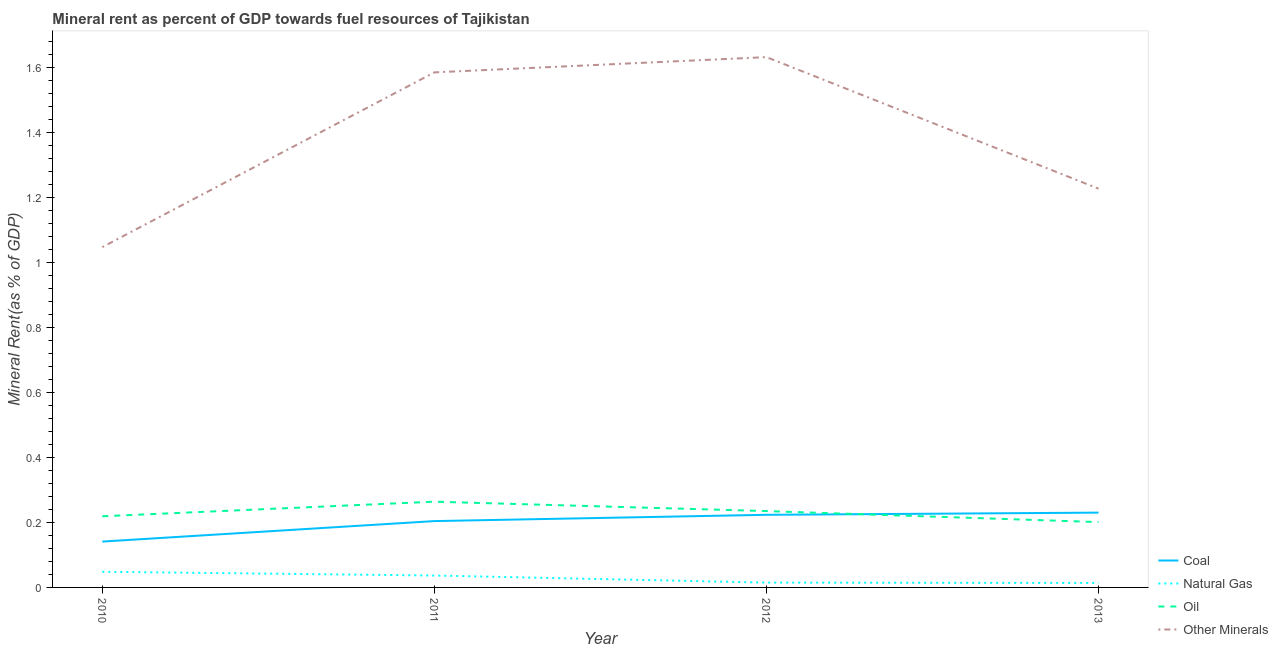How many different coloured lines are there?
Your answer should be very brief. 4. Is the number of lines equal to the number of legend labels?
Your response must be concise. Yes. What is the natural gas rent in 2011?
Your response must be concise. 0.04. Across all years, what is the maximum coal rent?
Offer a terse response. 0.23. Across all years, what is the minimum natural gas rent?
Make the answer very short. 0.01. In which year was the oil rent minimum?
Provide a short and direct response. 2013. What is the total coal rent in the graph?
Your answer should be very brief. 0.8. What is the difference between the  rent of other minerals in 2010 and that in 2013?
Ensure brevity in your answer.  -0.18. What is the difference between the oil rent in 2012 and the  rent of other minerals in 2013?
Offer a very short reply. -0.99. What is the average natural gas rent per year?
Offer a very short reply. 0.03. In the year 2010, what is the difference between the  rent of other minerals and oil rent?
Make the answer very short. 0.83. What is the ratio of the  rent of other minerals in 2011 to that in 2012?
Make the answer very short. 0.97. Is the difference between the natural gas rent in 2010 and 2011 greater than the difference between the oil rent in 2010 and 2011?
Offer a very short reply. Yes. What is the difference between the highest and the second highest  rent of other minerals?
Provide a short and direct response. 0.05. What is the difference between the highest and the lowest oil rent?
Provide a short and direct response. 0.06. In how many years, is the  rent of other minerals greater than the average  rent of other minerals taken over all years?
Make the answer very short. 2. Is the sum of the oil rent in 2011 and 2013 greater than the maximum natural gas rent across all years?
Give a very brief answer. Yes. Is it the case that in every year, the sum of the natural gas rent and oil rent is greater than the sum of coal rent and  rent of other minerals?
Ensure brevity in your answer.  No. Does the natural gas rent monotonically increase over the years?
Give a very brief answer. No. Is the oil rent strictly greater than the  rent of other minerals over the years?
Make the answer very short. No. How many lines are there?
Offer a very short reply. 4. What is the difference between two consecutive major ticks on the Y-axis?
Provide a short and direct response. 0.2. Does the graph contain any zero values?
Provide a short and direct response. No. How many legend labels are there?
Your answer should be compact. 4. What is the title of the graph?
Provide a succinct answer. Mineral rent as percent of GDP towards fuel resources of Tajikistan. Does "Mammal species" appear as one of the legend labels in the graph?
Ensure brevity in your answer.  No. What is the label or title of the Y-axis?
Ensure brevity in your answer.  Mineral Rent(as % of GDP). What is the Mineral Rent(as % of GDP) of Coal in 2010?
Make the answer very short. 0.14. What is the Mineral Rent(as % of GDP) of Natural Gas in 2010?
Your response must be concise. 0.05. What is the Mineral Rent(as % of GDP) in Oil in 2010?
Your answer should be compact. 0.22. What is the Mineral Rent(as % of GDP) in Other Minerals in 2010?
Keep it short and to the point. 1.05. What is the Mineral Rent(as % of GDP) in Coal in 2011?
Your answer should be compact. 0.2. What is the Mineral Rent(as % of GDP) of Natural Gas in 2011?
Your answer should be compact. 0.04. What is the Mineral Rent(as % of GDP) in Oil in 2011?
Provide a succinct answer. 0.26. What is the Mineral Rent(as % of GDP) of Other Minerals in 2011?
Your response must be concise. 1.58. What is the Mineral Rent(as % of GDP) of Coal in 2012?
Your answer should be very brief. 0.22. What is the Mineral Rent(as % of GDP) of Natural Gas in 2012?
Keep it short and to the point. 0.01. What is the Mineral Rent(as % of GDP) in Oil in 2012?
Keep it short and to the point. 0.23. What is the Mineral Rent(as % of GDP) in Other Minerals in 2012?
Ensure brevity in your answer.  1.63. What is the Mineral Rent(as % of GDP) in Coal in 2013?
Ensure brevity in your answer.  0.23. What is the Mineral Rent(as % of GDP) of Natural Gas in 2013?
Your answer should be compact. 0.01. What is the Mineral Rent(as % of GDP) of Oil in 2013?
Your answer should be compact. 0.2. What is the Mineral Rent(as % of GDP) in Other Minerals in 2013?
Make the answer very short. 1.23. Across all years, what is the maximum Mineral Rent(as % of GDP) in Coal?
Provide a short and direct response. 0.23. Across all years, what is the maximum Mineral Rent(as % of GDP) in Natural Gas?
Your response must be concise. 0.05. Across all years, what is the maximum Mineral Rent(as % of GDP) of Oil?
Offer a very short reply. 0.26. Across all years, what is the maximum Mineral Rent(as % of GDP) in Other Minerals?
Your answer should be very brief. 1.63. Across all years, what is the minimum Mineral Rent(as % of GDP) of Coal?
Offer a terse response. 0.14. Across all years, what is the minimum Mineral Rent(as % of GDP) in Natural Gas?
Ensure brevity in your answer.  0.01. Across all years, what is the minimum Mineral Rent(as % of GDP) of Oil?
Your response must be concise. 0.2. Across all years, what is the minimum Mineral Rent(as % of GDP) in Other Minerals?
Keep it short and to the point. 1.05. What is the total Mineral Rent(as % of GDP) in Coal in the graph?
Your answer should be very brief. 0.8. What is the total Mineral Rent(as % of GDP) of Natural Gas in the graph?
Keep it short and to the point. 0.11. What is the total Mineral Rent(as % of GDP) of Oil in the graph?
Offer a very short reply. 0.92. What is the total Mineral Rent(as % of GDP) of Other Minerals in the graph?
Your answer should be compact. 5.49. What is the difference between the Mineral Rent(as % of GDP) in Coal in 2010 and that in 2011?
Keep it short and to the point. -0.06. What is the difference between the Mineral Rent(as % of GDP) in Natural Gas in 2010 and that in 2011?
Offer a terse response. 0.01. What is the difference between the Mineral Rent(as % of GDP) in Oil in 2010 and that in 2011?
Offer a terse response. -0.04. What is the difference between the Mineral Rent(as % of GDP) of Other Minerals in 2010 and that in 2011?
Offer a terse response. -0.54. What is the difference between the Mineral Rent(as % of GDP) of Coal in 2010 and that in 2012?
Ensure brevity in your answer.  -0.08. What is the difference between the Mineral Rent(as % of GDP) of Natural Gas in 2010 and that in 2012?
Keep it short and to the point. 0.03. What is the difference between the Mineral Rent(as % of GDP) in Oil in 2010 and that in 2012?
Your answer should be compact. -0.02. What is the difference between the Mineral Rent(as % of GDP) of Other Minerals in 2010 and that in 2012?
Your answer should be very brief. -0.58. What is the difference between the Mineral Rent(as % of GDP) in Coal in 2010 and that in 2013?
Your answer should be very brief. -0.09. What is the difference between the Mineral Rent(as % of GDP) of Natural Gas in 2010 and that in 2013?
Keep it short and to the point. 0.03. What is the difference between the Mineral Rent(as % of GDP) in Oil in 2010 and that in 2013?
Ensure brevity in your answer.  0.02. What is the difference between the Mineral Rent(as % of GDP) in Other Minerals in 2010 and that in 2013?
Make the answer very short. -0.18. What is the difference between the Mineral Rent(as % of GDP) in Coal in 2011 and that in 2012?
Give a very brief answer. -0.02. What is the difference between the Mineral Rent(as % of GDP) in Natural Gas in 2011 and that in 2012?
Keep it short and to the point. 0.02. What is the difference between the Mineral Rent(as % of GDP) of Oil in 2011 and that in 2012?
Keep it short and to the point. 0.03. What is the difference between the Mineral Rent(as % of GDP) in Other Minerals in 2011 and that in 2012?
Your answer should be compact. -0.05. What is the difference between the Mineral Rent(as % of GDP) in Coal in 2011 and that in 2013?
Ensure brevity in your answer.  -0.03. What is the difference between the Mineral Rent(as % of GDP) of Natural Gas in 2011 and that in 2013?
Ensure brevity in your answer.  0.02. What is the difference between the Mineral Rent(as % of GDP) of Oil in 2011 and that in 2013?
Provide a succinct answer. 0.06. What is the difference between the Mineral Rent(as % of GDP) of Other Minerals in 2011 and that in 2013?
Your answer should be very brief. 0.36. What is the difference between the Mineral Rent(as % of GDP) in Coal in 2012 and that in 2013?
Offer a terse response. -0.01. What is the difference between the Mineral Rent(as % of GDP) in Natural Gas in 2012 and that in 2013?
Provide a short and direct response. 0. What is the difference between the Mineral Rent(as % of GDP) in Oil in 2012 and that in 2013?
Ensure brevity in your answer.  0.03. What is the difference between the Mineral Rent(as % of GDP) in Other Minerals in 2012 and that in 2013?
Your response must be concise. 0.4. What is the difference between the Mineral Rent(as % of GDP) in Coal in 2010 and the Mineral Rent(as % of GDP) in Natural Gas in 2011?
Your answer should be very brief. 0.1. What is the difference between the Mineral Rent(as % of GDP) in Coal in 2010 and the Mineral Rent(as % of GDP) in Oil in 2011?
Provide a succinct answer. -0.12. What is the difference between the Mineral Rent(as % of GDP) of Coal in 2010 and the Mineral Rent(as % of GDP) of Other Minerals in 2011?
Offer a very short reply. -1.44. What is the difference between the Mineral Rent(as % of GDP) in Natural Gas in 2010 and the Mineral Rent(as % of GDP) in Oil in 2011?
Your response must be concise. -0.22. What is the difference between the Mineral Rent(as % of GDP) in Natural Gas in 2010 and the Mineral Rent(as % of GDP) in Other Minerals in 2011?
Your response must be concise. -1.54. What is the difference between the Mineral Rent(as % of GDP) of Oil in 2010 and the Mineral Rent(as % of GDP) of Other Minerals in 2011?
Your response must be concise. -1.36. What is the difference between the Mineral Rent(as % of GDP) of Coal in 2010 and the Mineral Rent(as % of GDP) of Natural Gas in 2012?
Provide a short and direct response. 0.13. What is the difference between the Mineral Rent(as % of GDP) in Coal in 2010 and the Mineral Rent(as % of GDP) in Oil in 2012?
Your answer should be compact. -0.09. What is the difference between the Mineral Rent(as % of GDP) of Coal in 2010 and the Mineral Rent(as % of GDP) of Other Minerals in 2012?
Your answer should be compact. -1.49. What is the difference between the Mineral Rent(as % of GDP) of Natural Gas in 2010 and the Mineral Rent(as % of GDP) of Oil in 2012?
Your answer should be compact. -0.19. What is the difference between the Mineral Rent(as % of GDP) of Natural Gas in 2010 and the Mineral Rent(as % of GDP) of Other Minerals in 2012?
Your answer should be very brief. -1.58. What is the difference between the Mineral Rent(as % of GDP) of Oil in 2010 and the Mineral Rent(as % of GDP) of Other Minerals in 2012?
Provide a short and direct response. -1.41. What is the difference between the Mineral Rent(as % of GDP) in Coal in 2010 and the Mineral Rent(as % of GDP) in Natural Gas in 2013?
Your answer should be very brief. 0.13. What is the difference between the Mineral Rent(as % of GDP) in Coal in 2010 and the Mineral Rent(as % of GDP) in Oil in 2013?
Provide a short and direct response. -0.06. What is the difference between the Mineral Rent(as % of GDP) of Coal in 2010 and the Mineral Rent(as % of GDP) of Other Minerals in 2013?
Keep it short and to the point. -1.09. What is the difference between the Mineral Rent(as % of GDP) of Natural Gas in 2010 and the Mineral Rent(as % of GDP) of Oil in 2013?
Ensure brevity in your answer.  -0.15. What is the difference between the Mineral Rent(as % of GDP) of Natural Gas in 2010 and the Mineral Rent(as % of GDP) of Other Minerals in 2013?
Ensure brevity in your answer.  -1.18. What is the difference between the Mineral Rent(as % of GDP) in Oil in 2010 and the Mineral Rent(as % of GDP) in Other Minerals in 2013?
Make the answer very short. -1.01. What is the difference between the Mineral Rent(as % of GDP) of Coal in 2011 and the Mineral Rent(as % of GDP) of Natural Gas in 2012?
Make the answer very short. 0.19. What is the difference between the Mineral Rent(as % of GDP) in Coal in 2011 and the Mineral Rent(as % of GDP) in Oil in 2012?
Ensure brevity in your answer.  -0.03. What is the difference between the Mineral Rent(as % of GDP) of Coal in 2011 and the Mineral Rent(as % of GDP) of Other Minerals in 2012?
Provide a succinct answer. -1.43. What is the difference between the Mineral Rent(as % of GDP) in Natural Gas in 2011 and the Mineral Rent(as % of GDP) in Oil in 2012?
Offer a terse response. -0.2. What is the difference between the Mineral Rent(as % of GDP) in Natural Gas in 2011 and the Mineral Rent(as % of GDP) in Other Minerals in 2012?
Offer a very short reply. -1.59. What is the difference between the Mineral Rent(as % of GDP) in Oil in 2011 and the Mineral Rent(as % of GDP) in Other Minerals in 2012?
Ensure brevity in your answer.  -1.37. What is the difference between the Mineral Rent(as % of GDP) of Coal in 2011 and the Mineral Rent(as % of GDP) of Natural Gas in 2013?
Provide a succinct answer. 0.19. What is the difference between the Mineral Rent(as % of GDP) in Coal in 2011 and the Mineral Rent(as % of GDP) in Oil in 2013?
Your answer should be compact. 0. What is the difference between the Mineral Rent(as % of GDP) in Coal in 2011 and the Mineral Rent(as % of GDP) in Other Minerals in 2013?
Provide a short and direct response. -1.02. What is the difference between the Mineral Rent(as % of GDP) in Natural Gas in 2011 and the Mineral Rent(as % of GDP) in Oil in 2013?
Ensure brevity in your answer.  -0.16. What is the difference between the Mineral Rent(as % of GDP) in Natural Gas in 2011 and the Mineral Rent(as % of GDP) in Other Minerals in 2013?
Your response must be concise. -1.19. What is the difference between the Mineral Rent(as % of GDP) of Oil in 2011 and the Mineral Rent(as % of GDP) of Other Minerals in 2013?
Your answer should be very brief. -0.96. What is the difference between the Mineral Rent(as % of GDP) in Coal in 2012 and the Mineral Rent(as % of GDP) in Natural Gas in 2013?
Ensure brevity in your answer.  0.21. What is the difference between the Mineral Rent(as % of GDP) of Coal in 2012 and the Mineral Rent(as % of GDP) of Oil in 2013?
Your response must be concise. 0.02. What is the difference between the Mineral Rent(as % of GDP) of Coal in 2012 and the Mineral Rent(as % of GDP) of Other Minerals in 2013?
Make the answer very short. -1. What is the difference between the Mineral Rent(as % of GDP) of Natural Gas in 2012 and the Mineral Rent(as % of GDP) of Oil in 2013?
Keep it short and to the point. -0.19. What is the difference between the Mineral Rent(as % of GDP) in Natural Gas in 2012 and the Mineral Rent(as % of GDP) in Other Minerals in 2013?
Offer a terse response. -1.21. What is the difference between the Mineral Rent(as % of GDP) of Oil in 2012 and the Mineral Rent(as % of GDP) of Other Minerals in 2013?
Your answer should be compact. -0.99. What is the average Mineral Rent(as % of GDP) in Coal per year?
Your answer should be very brief. 0.2. What is the average Mineral Rent(as % of GDP) of Natural Gas per year?
Keep it short and to the point. 0.03. What is the average Mineral Rent(as % of GDP) in Oil per year?
Your answer should be very brief. 0.23. What is the average Mineral Rent(as % of GDP) in Other Minerals per year?
Offer a terse response. 1.37. In the year 2010, what is the difference between the Mineral Rent(as % of GDP) of Coal and Mineral Rent(as % of GDP) of Natural Gas?
Your response must be concise. 0.09. In the year 2010, what is the difference between the Mineral Rent(as % of GDP) of Coal and Mineral Rent(as % of GDP) of Oil?
Your answer should be very brief. -0.08. In the year 2010, what is the difference between the Mineral Rent(as % of GDP) of Coal and Mineral Rent(as % of GDP) of Other Minerals?
Keep it short and to the point. -0.91. In the year 2010, what is the difference between the Mineral Rent(as % of GDP) of Natural Gas and Mineral Rent(as % of GDP) of Oil?
Offer a very short reply. -0.17. In the year 2010, what is the difference between the Mineral Rent(as % of GDP) in Natural Gas and Mineral Rent(as % of GDP) in Other Minerals?
Offer a terse response. -1. In the year 2010, what is the difference between the Mineral Rent(as % of GDP) of Oil and Mineral Rent(as % of GDP) of Other Minerals?
Make the answer very short. -0.83. In the year 2011, what is the difference between the Mineral Rent(as % of GDP) in Coal and Mineral Rent(as % of GDP) in Natural Gas?
Make the answer very short. 0.17. In the year 2011, what is the difference between the Mineral Rent(as % of GDP) in Coal and Mineral Rent(as % of GDP) in Oil?
Keep it short and to the point. -0.06. In the year 2011, what is the difference between the Mineral Rent(as % of GDP) in Coal and Mineral Rent(as % of GDP) in Other Minerals?
Your answer should be very brief. -1.38. In the year 2011, what is the difference between the Mineral Rent(as % of GDP) in Natural Gas and Mineral Rent(as % of GDP) in Oil?
Make the answer very short. -0.23. In the year 2011, what is the difference between the Mineral Rent(as % of GDP) of Natural Gas and Mineral Rent(as % of GDP) of Other Minerals?
Provide a short and direct response. -1.55. In the year 2011, what is the difference between the Mineral Rent(as % of GDP) in Oil and Mineral Rent(as % of GDP) in Other Minerals?
Offer a terse response. -1.32. In the year 2012, what is the difference between the Mineral Rent(as % of GDP) in Coal and Mineral Rent(as % of GDP) in Natural Gas?
Your answer should be very brief. 0.21. In the year 2012, what is the difference between the Mineral Rent(as % of GDP) in Coal and Mineral Rent(as % of GDP) in Oil?
Make the answer very short. -0.01. In the year 2012, what is the difference between the Mineral Rent(as % of GDP) in Coal and Mineral Rent(as % of GDP) in Other Minerals?
Offer a terse response. -1.41. In the year 2012, what is the difference between the Mineral Rent(as % of GDP) of Natural Gas and Mineral Rent(as % of GDP) of Oil?
Ensure brevity in your answer.  -0.22. In the year 2012, what is the difference between the Mineral Rent(as % of GDP) of Natural Gas and Mineral Rent(as % of GDP) of Other Minerals?
Ensure brevity in your answer.  -1.62. In the year 2012, what is the difference between the Mineral Rent(as % of GDP) of Oil and Mineral Rent(as % of GDP) of Other Minerals?
Offer a very short reply. -1.4. In the year 2013, what is the difference between the Mineral Rent(as % of GDP) in Coal and Mineral Rent(as % of GDP) in Natural Gas?
Your answer should be compact. 0.22. In the year 2013, what is the difference between the Mineral Rent(as % of GDP) in Coal and Mineral Rent(as % of GDP) in Oil?
Offer a very short reply. 0.03. In the year 2013, what is the difference between the Mineral Rent(as % of GDP) of Coal and Mineral Rent(as % of GDP) of Other Minerals?
Keep it short and to the point. -1. In the year 2013, what is the difference between the Mineral Rent(as % of GDP) in Natural Gas and Mineral Rent(as % of GDP) in Oil?
Your response must be concise. -0.19. In the year 2013, what is the difference between the Mineral Rent(as % of GDP) in Natural Gas and Mineral Rent(as % of GDP) in Other Minerals?
Keep it short and to the point. -1.21. In the year 2013, what is the difference between the Mineral Rent(as % of GDP) of Oil and Mineral Rent(as % of GDP) of Other Minerals?
Give a very brief answer. -1.03. What is the ratio of the Mineral Rent(as % of GDP) in Coal in 2010 to that in 2011?
Your answer should be very brief. 0.69. What is the ratio of the Mineral Rent(as % of GDP) in Natural Gas in 2010 to that in 2011?
Offer a very short reply. 1.31. What is the ratio of the Mineral Rent(as % of GDP) in Oil in 2010 to that in 2011?
Your answer should be very brief. 0.83. What is the ratio of the Mineral Rent(as % of GDP) of Other Minerals in 2010 to that in 2011?
Offer a very short reply. 0.66. What is the ratio of the Mineral Rent(as % of GDP) of Coal in 2010 to that in 2012?
Offer a very short reply. 0.63. What is the ratio of the Mineral Rent(as % of GDP) in Natural Gas in 2010 to that in 2012?
Your answer should be compact. 3.24. What is the ratio of the Mineral Rent(as % of GDP) in Oil in 2010 to that in 2012?
Your answer should be very brief. 0.93. What is the ratio of the Mineral Rent(as % of GDP) of Other Minerals in 2010 to that in 2012?
Provide a succinct answer. 0.64. What is the ratio of the Mineral Rent(as % of GDP) in Coal in 2010 to that in 2013?
Provide a short and direct response. 0.61. What is the ratio of the Mineral Rent(as % of GDP) of Natural Gas in 2010 to that in 2013?
Make the answer very short. 3.51. What is the ratio of the Mineral Rent(as % of GDP) in Oil in 2010 to that in 2013?
Your response must be concise. 1.09. What is the ratio of the Mineral Rent(as % of GDP) in Other Minerals in 2010 to that in 2013?
Offer a very short reply. 0.85. What is the ratio of the Mineral Rent(as % of GDP) of Coal in 2011 to that in 2012?
Keep it short and to the point. 0.91. What is the ratio of the Mineral Rent(as % of GDP) of Natural Gas in 2011 to that in 2012?
Offer a very short reply. 2.47. What is the ratio of the Mineral Rent(as % of GDP) of Oil in 2011 to that in 2012?
Your response must be concise. 1.12. What is the ratio of the Mineral Rent(as % of GDP) in Other Minerals in 2011 to that in 2012?
Ensure brevity in your answer.  0.97. What is the ratio of the Mineral Rent(as % of GDP) of Coal in 2011 to that in 2013?
Offer a terse response. 0.89. What is the ratio of the Mineral Rent(as % of GDP) in Natural Gas in 2011 to that in 2013?
Provide a short and direct response. 2.67. What is the ratio of the Mineral Rent(as % of GDP) of Oil in 2011 to that in 2013?
Make the answer very short. 1.31. What is the ratio of the Mineral Rent(as % of GDP) in Other Minerals in 2011 to that in 2013?
Give a very brief answer. 1.29. What is the ratio of the Mineral Rent(as % of GDP) in Coal in 2012 to that in 2013?
Your answer should be very brief. 0.97. What is the ratio of the Mineral Rent(as % of GDP) of Natural Gas in 2012 to that in 2013?
Offer a very short reply. 1.08. What is the ratio of the Mineral Rent(as % of GDP) in Oil in 2012 to that in 2013?
Ensure brevity in your answer.  1.17. What is the ratio of the Mineral Rent(as % of GDP) in Other Minerals in 2012 to that in 2013?
Keep it short and to the point. 1.33. What is the difference between the highest and the second highest Mineral Rent(as % of GDP) of Coal?
Offer a terse response. 0.01. What is the difference between the highest and the second highest Mineral Rent(as % of GDP) of Natural Gas?
Give a very brief answer. 0.01. What is the difference between the highest and the second highest Mineral Rent(as % of GDP) in Oil?
Your answer should be compact. 0.03. What is the difference between the highest and the second highest Mineral Rent(as % of GDP) of Other Minerals?
Your response must be concise. 0.05. What is the difference between the highest and the lowest Mineral Rent(as % of GDP) of Coal?
Offer a very short reply. 0.09. What is the difference between the highest and the lowest Mineral Rent(as % of GDP) in Natural Gas?
Your response must be concise. 0.03. What is the difference between the highest and the lowest Mineral Rent(as % of GDP) in Oil?
Your response must be concise. 0.06. What is the difference between the highest and the lowest Mineral Rent(as % of GDP) in Other Minerals?
Give a very brief answer. 0.58. 